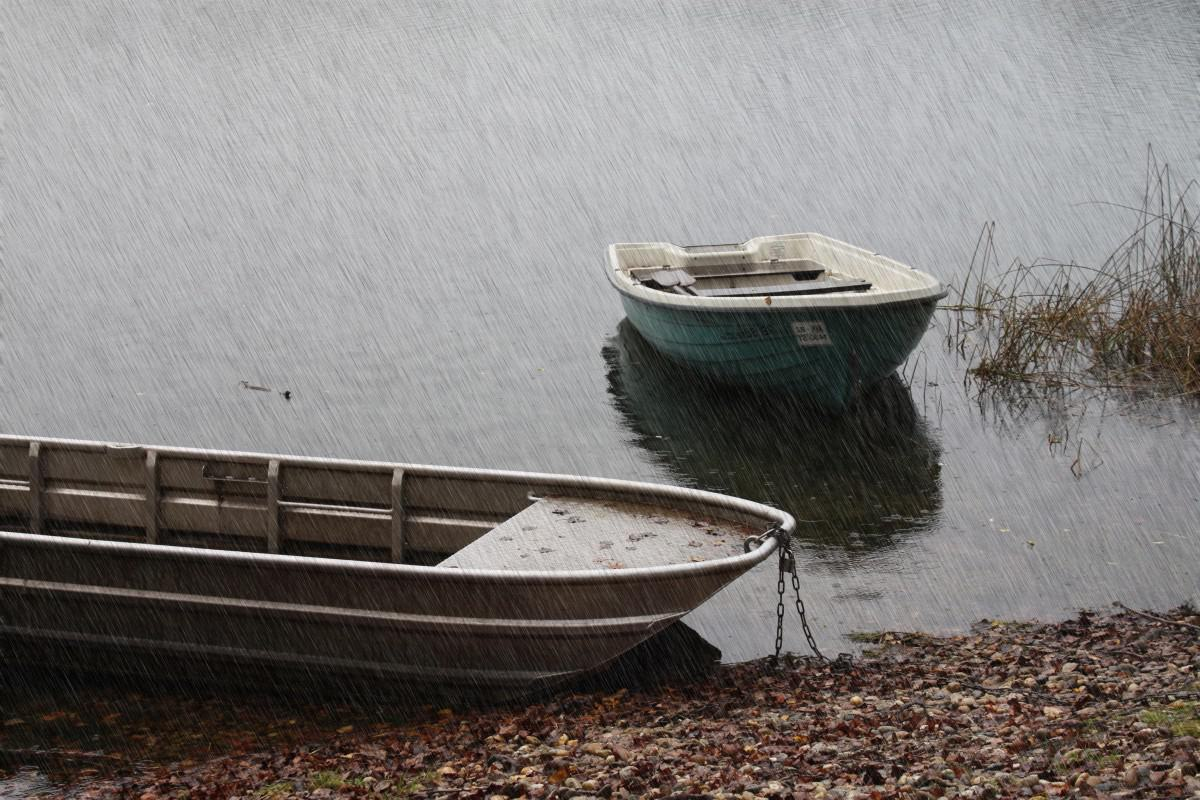How many boats are there in the image? 2 